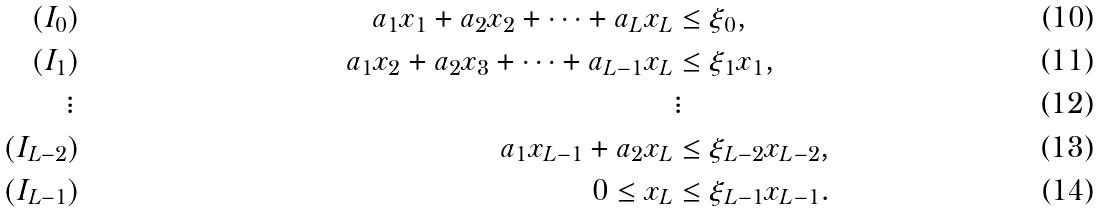Convert formula to latex. <formula><loc_0><loc_0><loc_500><loc_500>( I _ { 0 } ) & & a _ { 1 } x _ { 1 } + a _ { 2 } x _ { 2 } + \cdots + a _ { L } x _ { L } & \leq \xi _ { 0 } , \\ ( I _ { 1 } ) & & a _ { 1 } x _ { 2 } + a _ { 2 } x _ { 3 } + \cdots + a _ { L - 1 } x _ { L } & \leq \xi _ { 1 } x _ { 1 } , \\ \vdots \, & & & \vdots \\ ( I _ { L - 2 } ) & & a _ { 1 } x _ { L - 1 } + a _ { 2 } x _ { L } & \leq \xi _ { L - 2 } x _ { L - 2 } , \\ ( I _ { L - 1 } ) & & 0 \leq x _ { L } & \leq \xi _ { L - 1 } x _ { L - 1 } .</formula> 